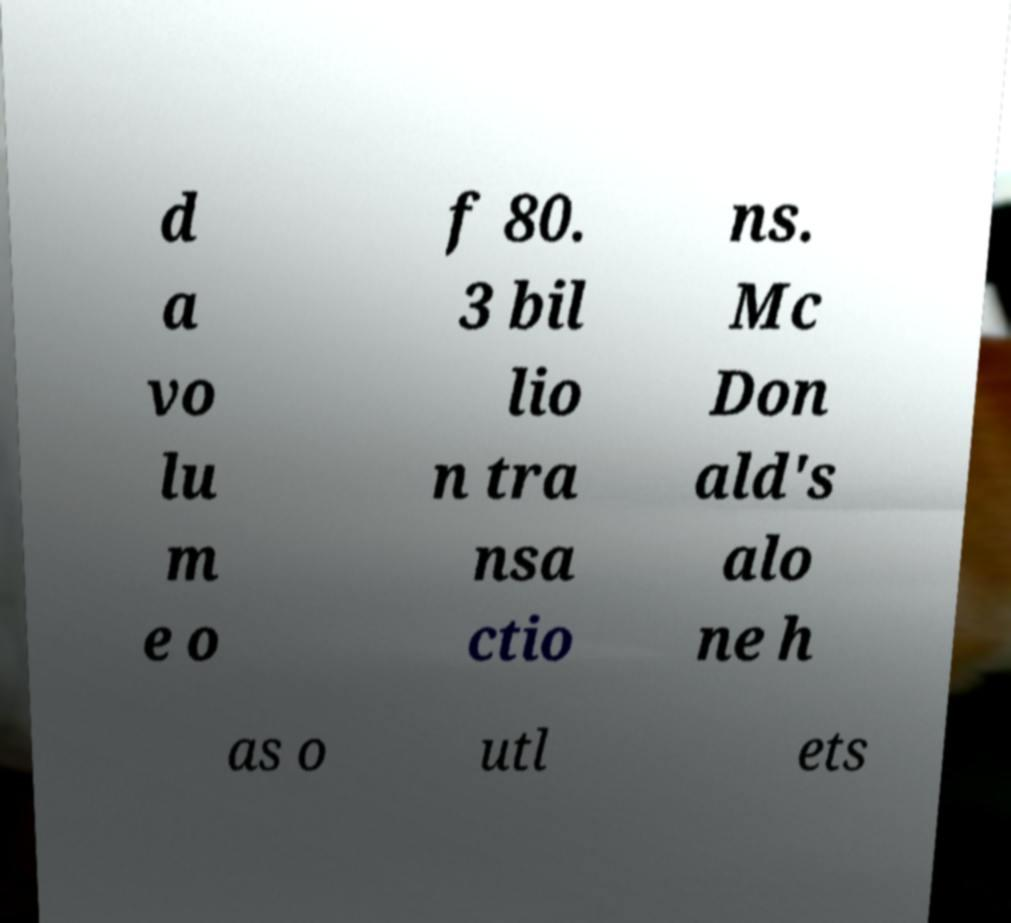There's text embedded in this image that I need extracted. Can you transcribe it verbatim? d a vo lu m e o f 80. 3 bil lio n tra nsa ctio ns. Mc Don ald's alo ne h as o utl ets 